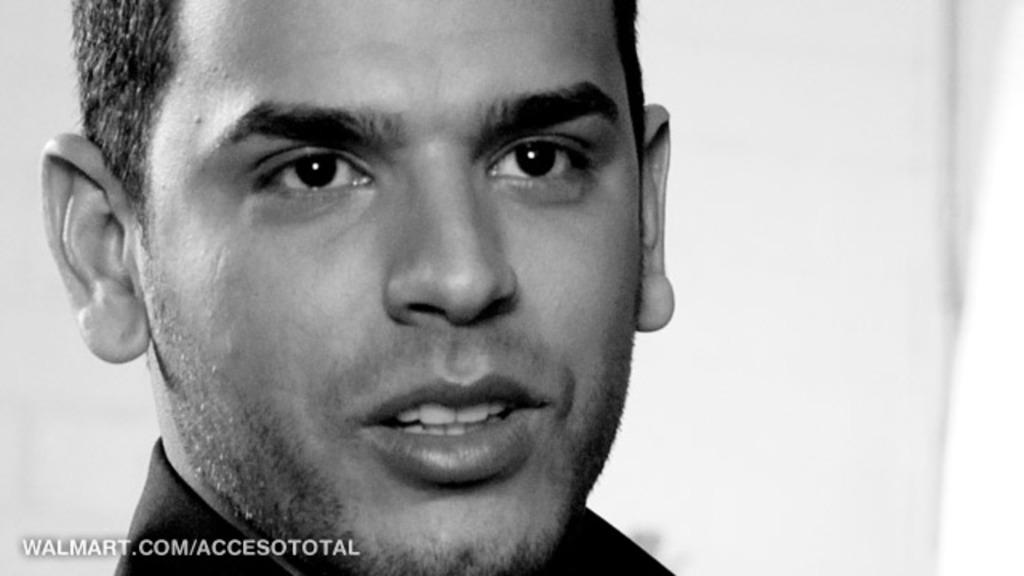What is the main subject of the image? There is a man's face in the image. Is there any text or logo visible in the image? Yes, there is a watermark in the bottom left corner of the image. What color is the background of the image? The background of the image is white. What type of pan can be seen on the market in the image? There is no pan or market present in the image; it features a man's face and a watermark on a white background. 